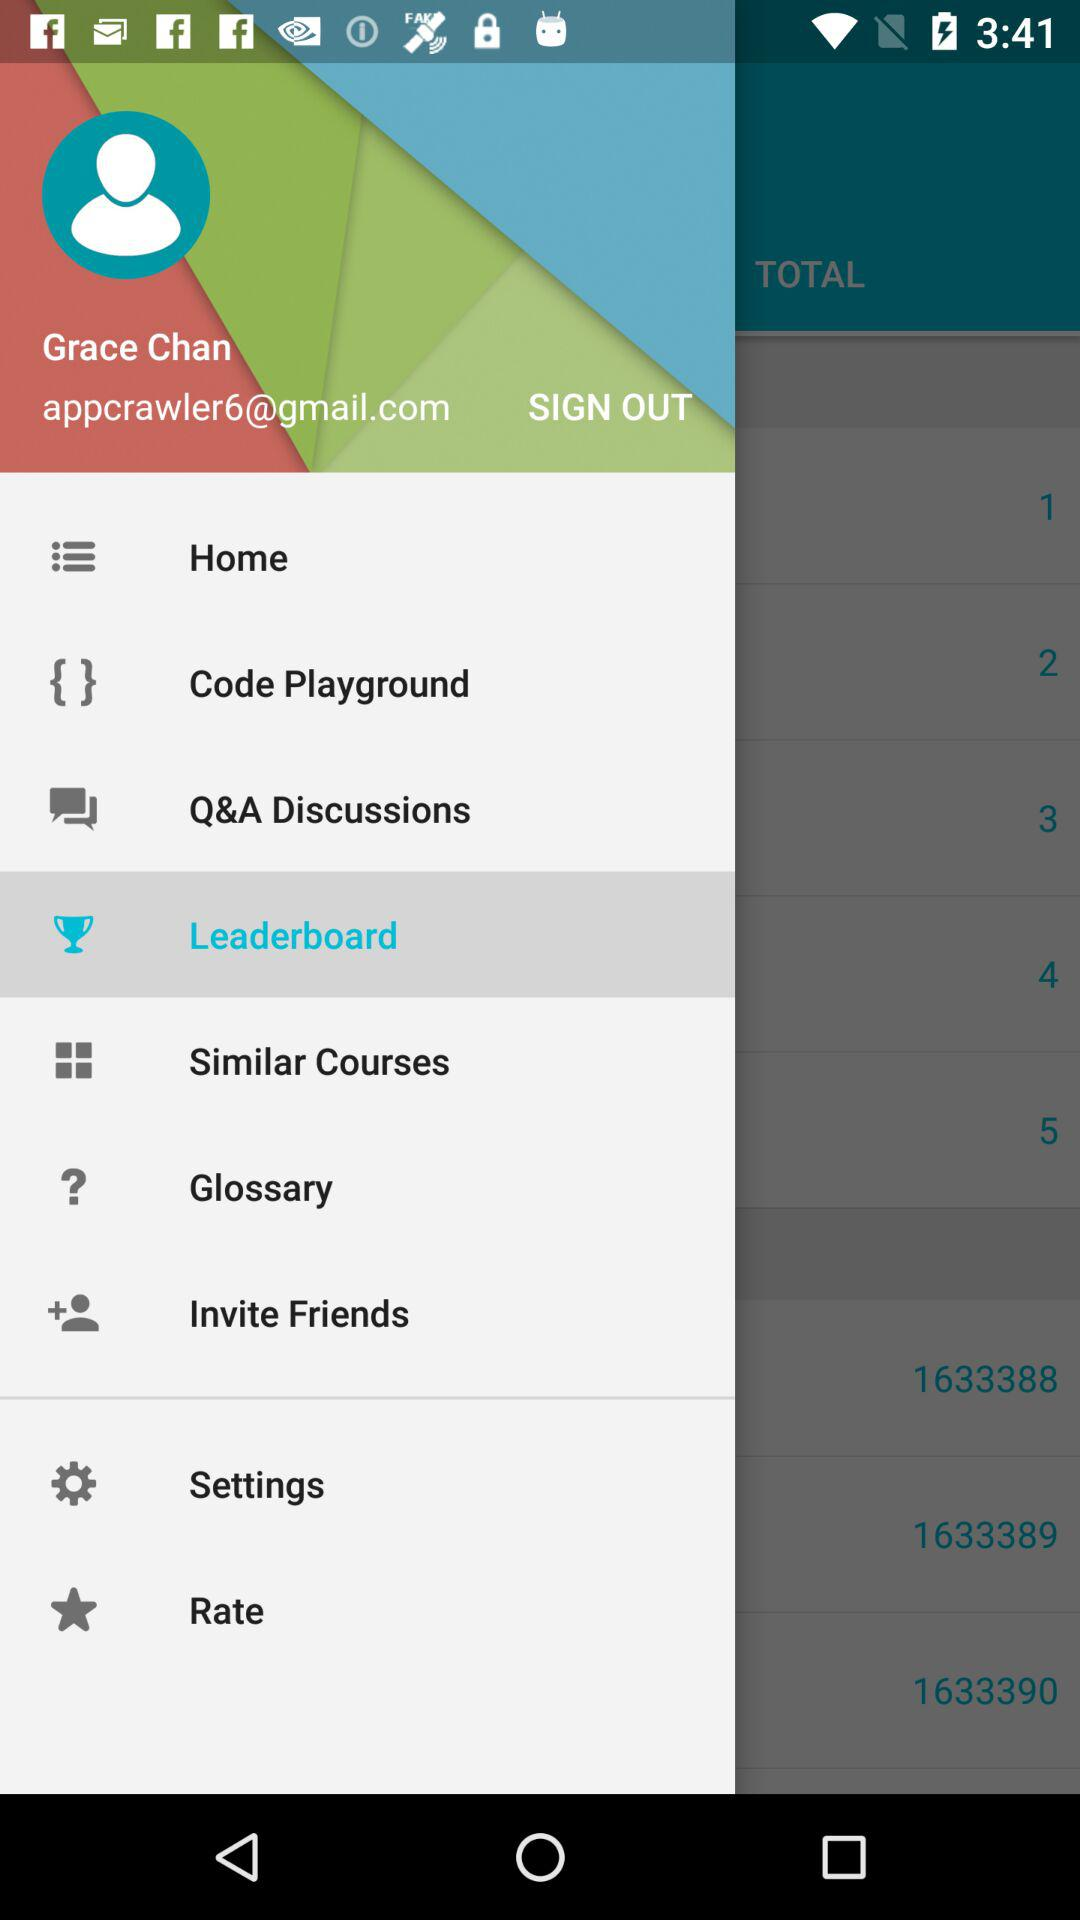What is the email address? The email address is appcrawler6@gmail.com. 